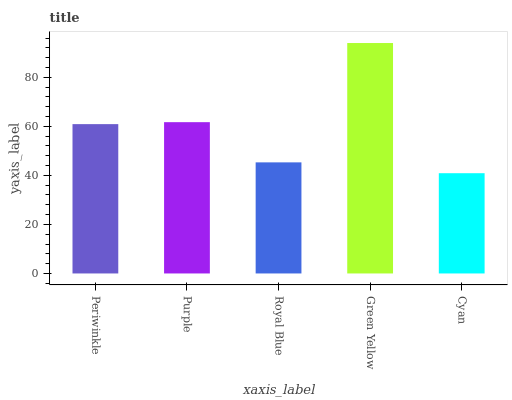Is Cyan the minimum?
Answer yes or no. Yes. Is Green Yellow the maximum?
Answer yes or no. Yes. Is Purple the minimum?
Answer yes or no. No. Is Purple the maximum?
Answer yes or no. No. Is Purple greater than Periwinkle?
Answer yes or no. Yes. Is Periwinkle less than Purple?
Answer yes or no. Yes. Is Periwinkle greater than Purple?
Answer yes or no. No. Is Purple less than Periwinkle?
Answer yes or no. No. Is Periwinkle the high median?
Answer yes or no. Yes. Is Periwinkle the low median?
Answer yes or no. Yes. Is Cyan the high median?
Answer yes or no. No. Is Green Yellow the low median?
Answer yes or no. No. 